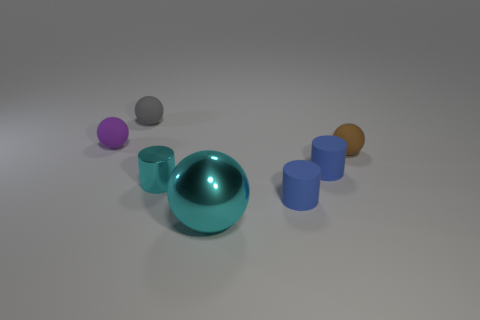Is there a ball of the same color as the large object?
Your answer should be compact. No. Does the tiny metal cylinder have the same color as the large metal thing?
Give a very brief answer. Yes. What material is the sphere in front of the rubber sphere in front of the matte object left of the gray rubber ball?
Your answer should be compact. Metal. Does the small rubber object behind the small purple rubber ball have the same shape as the thing left of the gray ball?
Make the answer very short. Yes. What number of other things are there of the same material as the brown thing
Provide a short and direct response. 4. Is the small cylinder behind the small cyan metallic object made of the same material as the cyan object left of the big thing?
Offer a terse response. No. What is the shape of the cyan thing that is the same material as the big ball?
Ensure brevity in your answer.  Cylinder. Is there any other thing that is the same color as the small shiny cylinder?
Give a very brief answer. Yes. How many large green matte cylinders are there?
Your answer should be very brief. 0. There is a rubber thing that is on the left side of the cyan ball and right of the purple ball; what is its shape?
Your response must be concise. Sphere. 